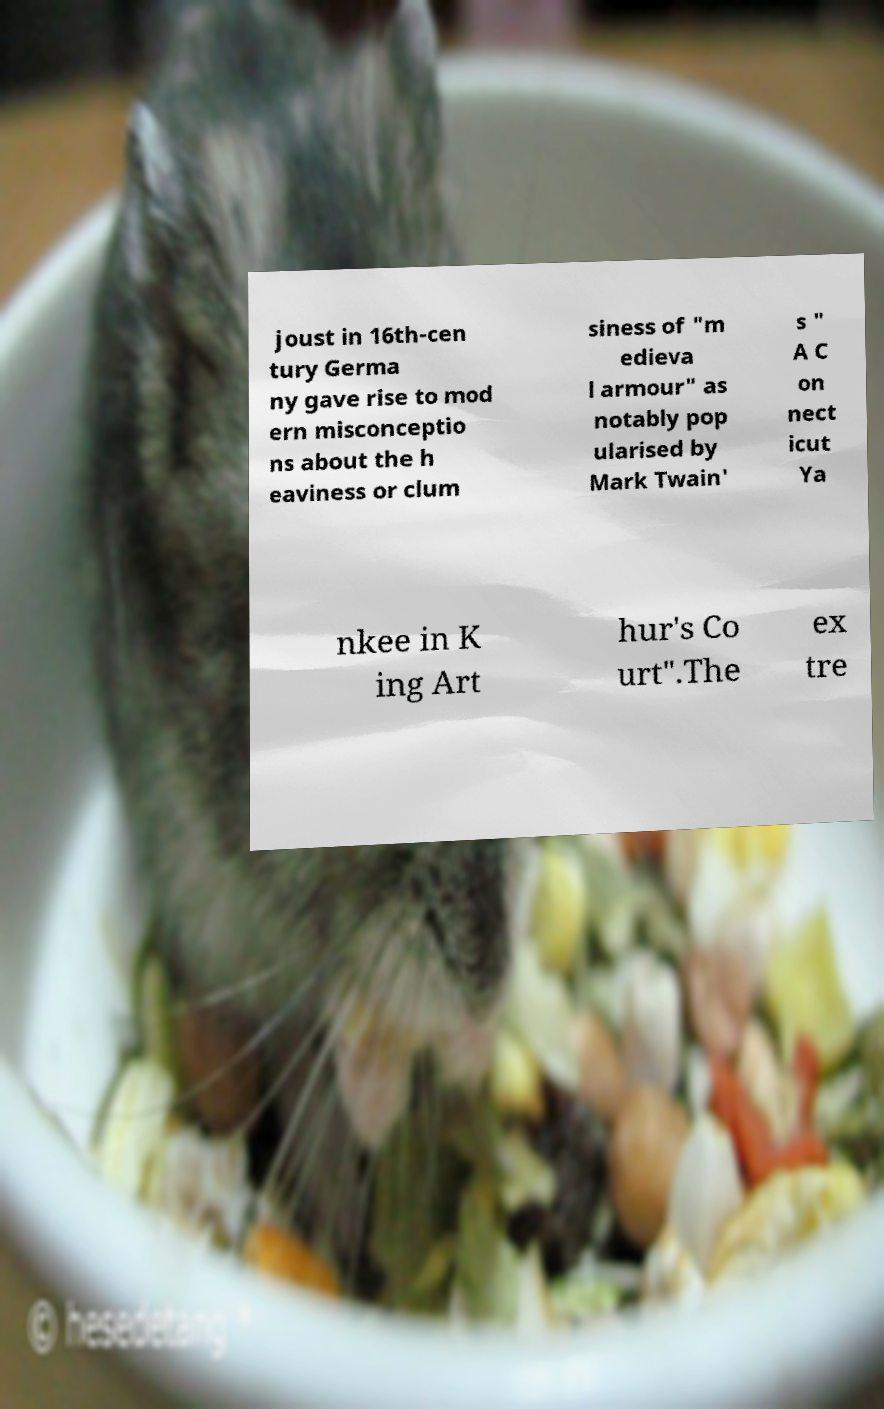Could you extract and type out the text from this image? joust in 16th-cen tury Germa ny gave rise to mod ern misconceptio ns about the h eaviness or clum siness of "m edieva l armour" as notably pop ularised by Mark Twain' s " A C on nect icut Ya nkee in K ing Art hur's Co urt".The ex tre 